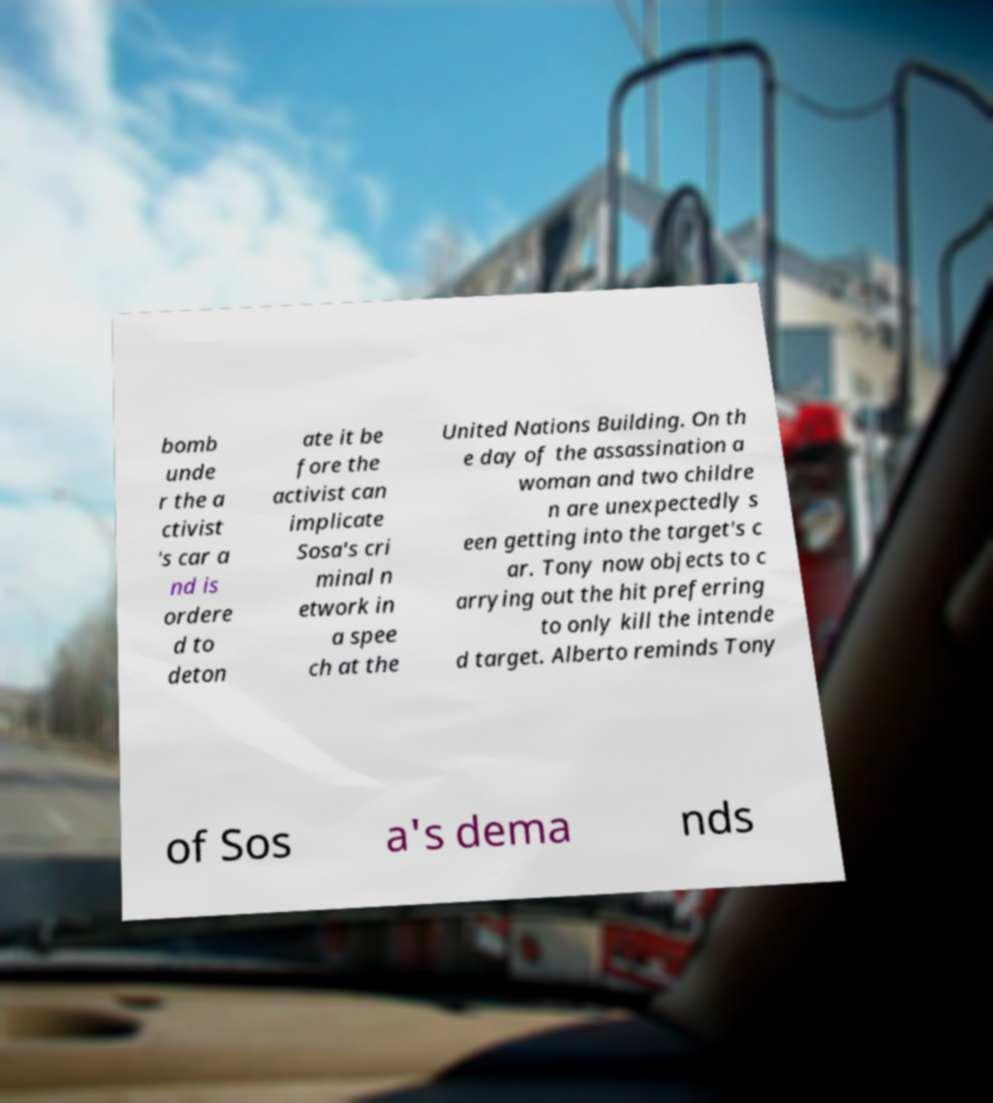Can you accurately transcribe the text from the provided image for me? bomb unde r the a ctivist 's car a nd is ordere d to deton ate it be fore the activist can implicate Sosa's cri minal n etwork in a spee ch at the United Nations Building. On th e day of the assassination a woman and two childre n are unexpectedly s een getting into the target's c ar. Tony now objects to c arrying out the hit preferring to only kill the intende d target. Alberto reminds Tony of Sos a's dema nds 